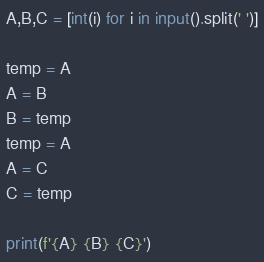<code> <loc_0><loc_0><loc_500><loc_500><_Python_>A,B,C = [int(i) for i in input().split(' ')]

temp = A
A = B
B = temp
temp = A
A = C
C = temp

print(f'{A} {B} {C}')</code> 